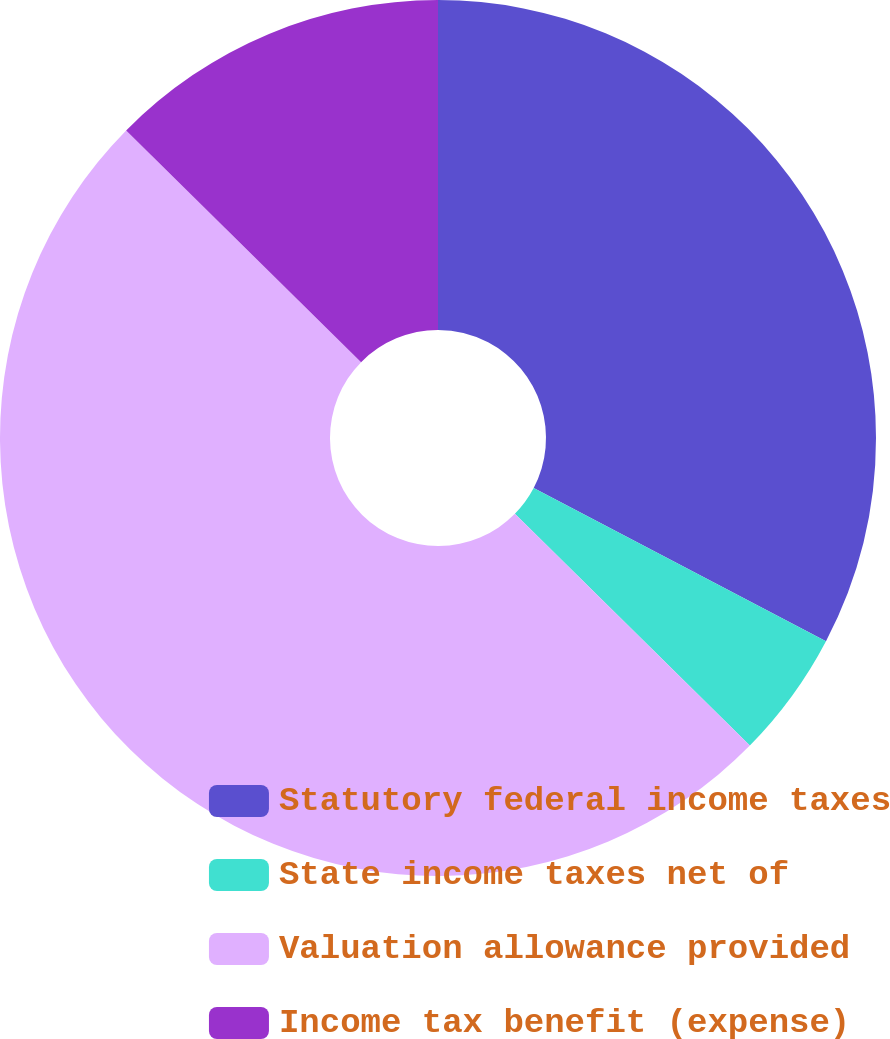Convert chart. <chart><loc_0><loc_0><loc_500><loc_500><pie_chart><fcel>Statutory federal income taxes<fcel>State income taxes net of<fcel>Valuation allowance provided<fcel>Income tax benefit (expense)<nl><fcel>32.68%<fcel>4.71%<fcel>50.0%<fcel>12.61%<nl></chart> 